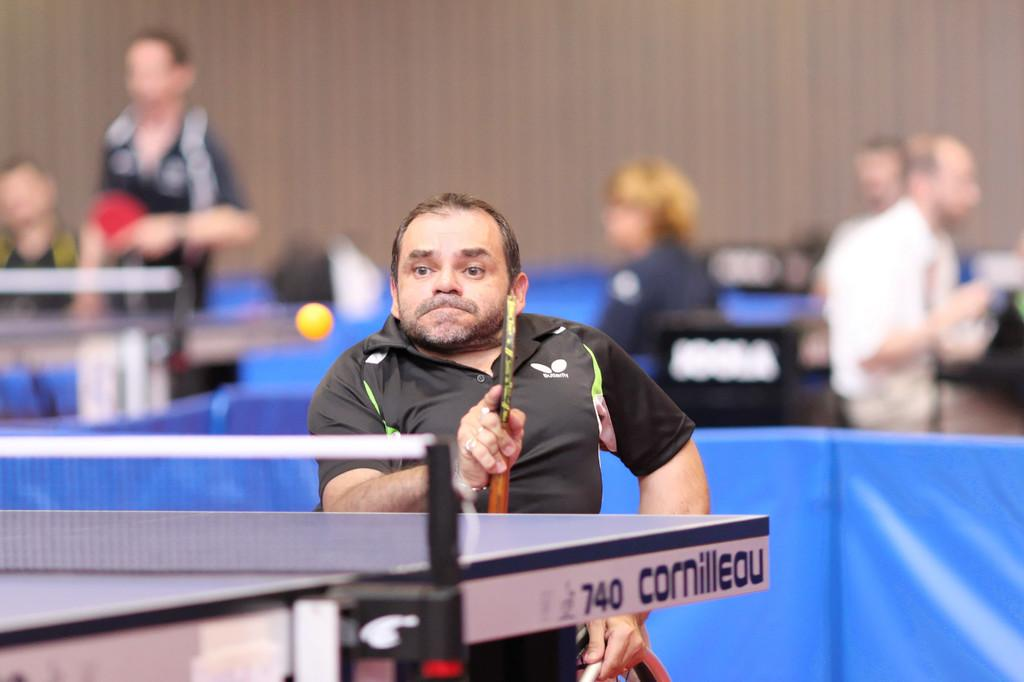Who is present in the image? There is a man in the image. What is the man holding in the image? The man is holding a bat. Where is the man standing in the image? The man is standing in front of a table. What else can be seen in the image besides the man and the table? There is a ball in the image. Can you describe the background of the image? There are people visible in the background of the image. What type of deer can be seen running through the waves in the image? There are no deer or waves present in the image; it features a man holding a bat, a ball, and people in the background. 